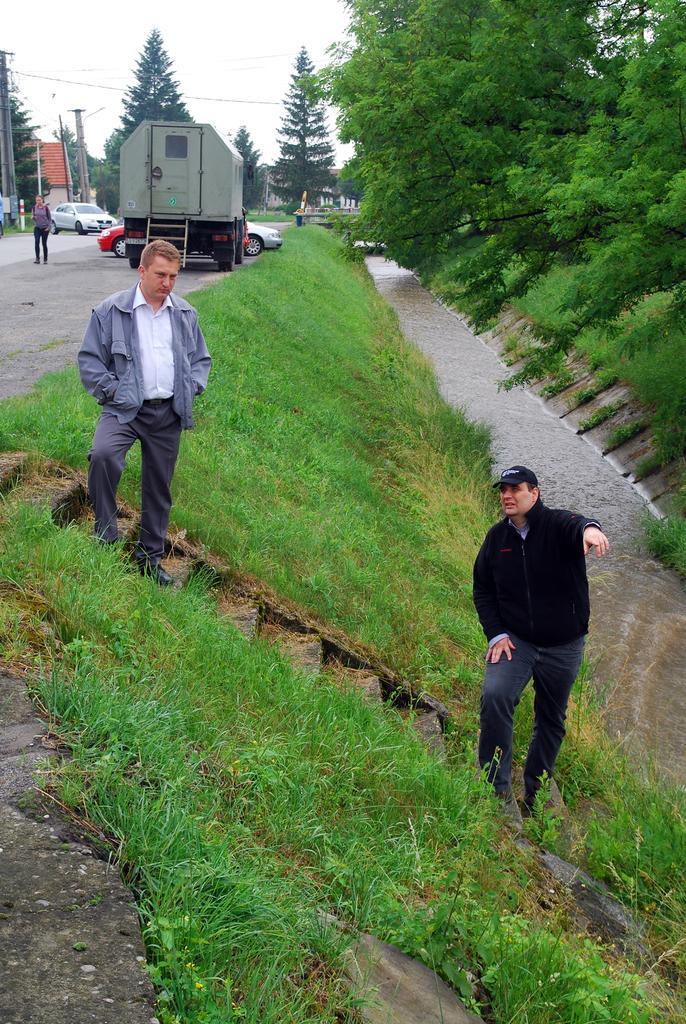How would you summarize this image in a sentence or two? On the right there is a man who is wearing black dress. He is standing on the stairs, beside him we can see the water and grass. On the left there is another man who is wearing jacket, shirt, trouser and shoe, beside that we can see the trucks and cars on the road. In the background we can see many trees, electric poles and building. At the top there is a sky. 